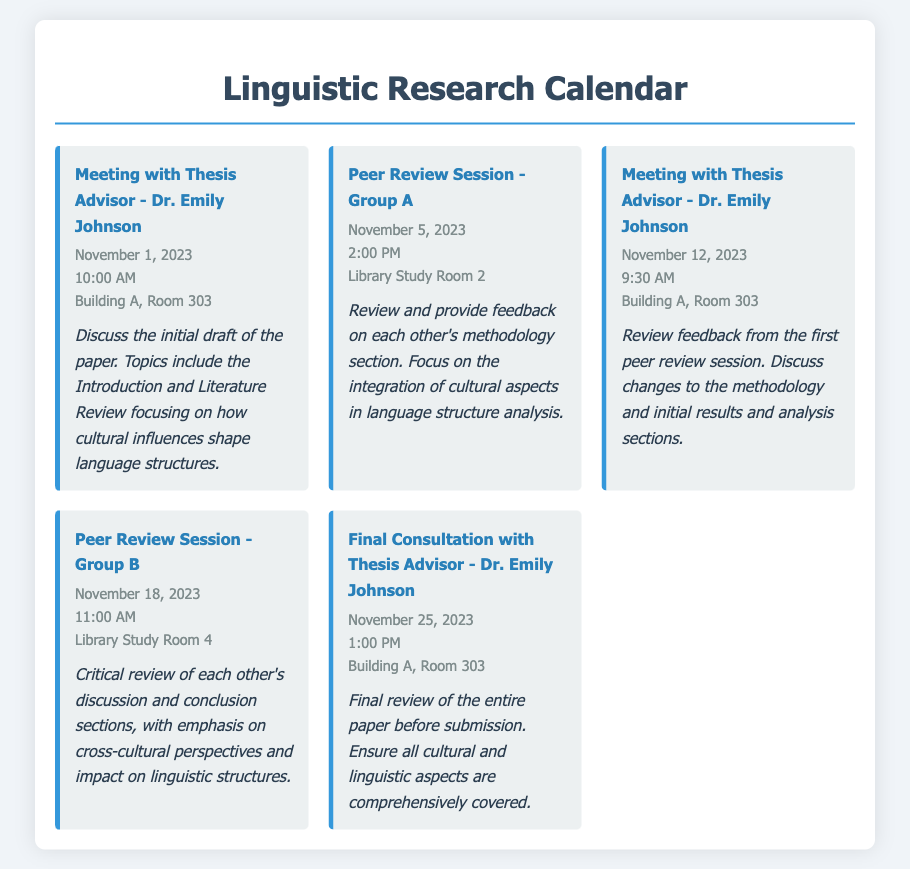What is the date of the first meeting with Dr. Emily Johnson? The first meeting with Dr. Emily Johnson is scheduled for November 1, 2023.
Answer: November 1, 2023 What time is the Peer Review Session for Group A? The Peer Review Session for Group A is at 2:00 PM.
Answer: 2:00 PM Which room is the final consultation with the thesis advisor held in? The final consultation with Dr. Emily Johnson is held in Building A, Room 303.
Answer: Building A, Room 303 What is the focus of the discussion in the Peer Review Session - Group B? The focus of the discussion in the Peer Review Session - Group B is on cross-cultural perspectives and impact on linguistic structures.
Answer: Cross-cultural perspectives and impact on linguistic structures How many meetings are scheduled with Dr. Emily Johnson? There are three meetings scheduled with Dr. Emily Johnson.
Answer: Three What section of the paper is to be reviewed in the first Peer Review Session? The section to be reviewed in the first Peer Review Session is the methodology section.
Answer: Methodology section When will the final review of the entire paper take place? The final review of the entire paper will take place on November 25, 2023.
Answer: November 25, 2023 What is emphasized in the first discussion with the thesis advisor? The emphasis in the first discussion with Dr. Emily Johnson is on the Introduction and Literature Review.
Answer: Introduction and Literature Review 